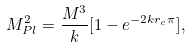<formula> <loc_0><loc_0><loc_500><loc_500>M _ { P l } ^ { 2 } = \frac { M ^ { 3 } } { k } [ 1 - e ^ { - 2 k r _ { c } \pi } ] ,</formula> 